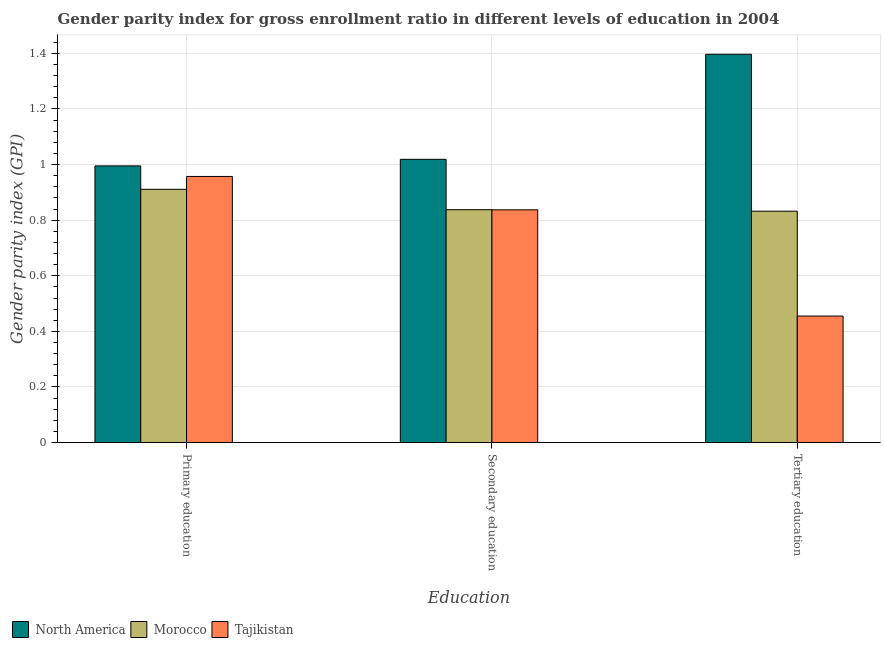How many different coloured bars are there?
Your answer should be very brief. 3. How many groups of bars are there?
Your answer should be compact. 3. How many bars are there on the 1st tick from the right?
Provide a short and direct response. 3. What is the label of the 3rd group of bars from the left?
Ensure brevity in your answer.  Tertiary education. What is the gender parity index in primary education in Morocco?
Give a very brief answer. 0.91. Across all countries, what is the maximum gender parity index in secondary education?
Offer a very short reply. 1.02. Across all countries, what is the minimum gender parity index in secondary education?
Your answer should be very brief. 0.84. In which country was the gender parity index in primary education minimum?
Provide a short and direct response. Morocco. What is the total gender parity index in secondary education in the graph?
Your answer should be very brief. 2.69. What is the difference between the gender parity index in primary education in Morocco and that in North America?
Provide a short and direct response. -0.08. What is the difference between the gender parity index in primary education in North America and the gender parity index in tertiary education in Tajikistan?
Provide a short and direct response. 0.54. What is the average gender parity index in primary education per country?
Keep it short and to the point. 0.95. What is the difference between the gender parity index in tertiary education and gender parity index in secondary education in Morocco?
Offer a terse response. -0.01. What is the ratio of the gender parity index in secondary education in North America to that in Tajikistan?
Keep it short and to the point. 1.22. Is the gender parity index in tertiary education in North America less than that in Tajikistan?
Make the answer very short. No. Is the difference between the gender parity index in tertiary education in Morocco and North America greater than the difference between the gender parity index in secondary education in Morocco and North America?
Provide a short and direct response. No. What is the difference between the highest and the second highest gender parity index in secondary education?
Provide a succinct answer. 0.18. What is the difference between the highest and the lowest gender parity index in secondary education?
Your answer should be very brief. 0.18. What does the 2nd bar from the left in Primary education represents?
Make the answer very short. Morocco. What does the 2nd bar from the right in Secondary education represents?
Make the answer very short. Morocco. How many bars are there?
Keep it short and to the point. 9. What is the difference between two consecutive major ticks on the Y-axis?
Offer a terse response. 0.2. Are the values on the major ticks of Y-axis written in scientific E-notation?
Your answer should be compact. No. How many legend labels are there?
Your answer should be compact. 3. How are the legend labels stacked?
Your answer should be compact. Horizontal. What is the title of the graph?
Your answer should be compact. Gender parity index for gross enrollment ratio in different levels of education in 2004. Does "Sri Lanka" appear as one of the legend labels in the graph?
Make the answer very short. No. What is the label or title of the X-axis?
Ensure brevity in your answer.  Education. What is the label or title of the Y-axis?
Give a very brief answer. Gender parity index (GPI). What is the Gender parity index (GPI) of North America in Primary education?
Ensure brevity in your answer.  1. What is the Gender parity index (GPI) of Morocco in Primary education?
Give a very brief answer. 0.91. What is the Gender parity index (GPI) in Tajikistan in Primary education?
Provide a short and direct response. 0.96. What is the Gender parity index (GPI) of North America in Secondary education?
Ensure brevity in your answer.  1.02. What is the Gender parity index (GPI) of Morocco in Secondary education?
Your answer should be very brief. 0.84. What is the Gender parity index (GPI) in Tajikistan in Secondary education?
Your answer should be very brief. 0.84. What is the Gender parity index (GPI) of North America in Tertiary education?
Your answer should be very brief. 1.4. What is the Gender parity index (GPI) of Morocco in Tertiary education?
Keep it short and to the point. 0.83. What is the Gender parity index (GPI) of Tajikistan in Tertiary education?
Give a very brief answer. 0.46. Across all Education, what is the maximum Gender parity index (GPI) in North America?
Offer a very short reply. 1.4. Across all Education, what is the maximum Gender parity index (GPI) of Morocco?
Provide a succinct answer. 0.91. Across all Education, what is the maximum Gender parity index (GPI) of Tajikistan?
Offer a terse response. 0.96. Across all Education, what is the minimum Gender parity index (GPI) of North America?
Give a very brief answer. 1. Across all Education, what is the minimum Gender parity index (GPI) in Morocco?
Provide a succinct answer. 0.83. Across all Education, what is the minimum Gender parity index (GPI) in Tajikistan?
Your answer should be very brief. 0.46. What is the total Gender parity index (GPI) in North America in the graph?
Your answer should be very brief. 3.41. What is the total Gender parity index (GPI) of Morocco in the graph?
Offer a very short reply. 2.58. What is the total Gender parity index (GPI) of Tajikistan in the graph?
Provide a short and direct response. 2.25. What is the difference between the Gender parity index (GPI) of North America in Primary education and that in Secondary education?
Make the answer very short. -0.02. What is the difference between the Gender parity index (GPI) in Morocco in Primary education and that in Secondary education?
Provide a short and direct response. 0.07. What is the difference between the Gender parity index (GPI) of Tajikistan in Primary education and that in Secondary education?
Offer a terse response. 0.12. What is the difference between the Gender parity index (GPI) of North America in Primary education and that in Tertiary education?
Your response must be concise. -0.4. What is the difference between the Gender parity index (GPI) in Morocco in Primary education and that in Tertiary education?
Your response must be concise. 0.08. What is the difference between the Gender parity index (GPI) in Tajikistan in Primary education and that in Tertiary education?
Offer a terse response. 0.5. What is the difference between the Gender parity index (GPI) of North America in Secondary education and that in Tertiary education?
Your answer should be very brief. -0.38. What is the difference between the Gender parity index (GPI) of Morocco in Secondary education and that in Tertiary education?
Your answer should be very brief. 0.01. What is the difference between the Gender parity index (GPI) of Tajikistan in Secondary education and that in Tertiary education?
Make the answer very short. 0.38. What is the difference between the Gender parity index (GPI) of North America in Primary education and the Gender parity index (GPI) of Morocco in Secondary education?
Your answer should be compact. 0.16. What is the difference between the Gender parity index (GPI) of North America in Primary education and the Gender parity index (GPI) of Tajikistan in Secondary education?
Offer a very short reply. 0.16. What is the difference between the Gender parity index (GPI) of Morocco in Primary education and the Gender parity index (GPI) of Tajikistan in Secondary education?
Ensure brevity in your answer.  0.07. What is the difference between the Gender parity index (GPI) of North America in Primary education and the Gender parity index (GPI) of Morocco in Tertiary education?
Offer a terse response. 0.16. What is the difference between the Gender parity index (GPI) in North America in Primary education and the Gender parity index (GPI) in Tajikistan in Tertiary education?
Offer a terse response. 0.54. What is the difference between the Gender parity index (GPI) in Morocco in Primary education and the Gender parity index (GPI) in Tajikistan in Tertiary education?
Your answer should be compact. 0.46. What is the difference between the Gender parity index (GPI) of North America in Secondary education and the Gender parity index (GPI) of Morocco in Tertiary education?
Ensure brevity in your answer.  0.19. What is the difference between the Gender parity index (GPI) of North America in Secondary education and the Gender parity index (GPI) of Tajikistan in Tertiary education?
Your response must be concise. 0.56. What is the difference between the Gender parity index (GPI) in Morocco in Secondary education and the Gender parity index (GPI) in Tajikistan in Tertiary education?
Ensure brevity in your answer.  0.38. What is the average Gender parity index (GPI) in North America per Education?
Provide a short and direct response. 1.14. What is the average Gender parity index (GPI) in Morocco per Education?
Keep it short and to the point. 0.86. What is the average Gender parity index (GPI) of Tajikistan per Education?
Offer a terse response. 0.75. What is the difference between the Gender parity index (GPI) of North America and Gender parity index (GPI) of Morocco in Primary education?
Provide a short and direct response. 0.08. What is the difference between the Gender parity index (GPI) of North America and Gender parity index (GPI) of Tajikistan in Primary education?
Provide a succinct answer. 0.04. What is the difference between the Gender parity index (GPI) in Morocco and Gender parity index (GPI) in Tajikistan in Primary education?
Offer a very short reply. -0.05. What is the difference between the Gender parity index (GPI) of North America and Gender parity index (GPI) of Morocco in Secondary education?
Keep it short and to the point. 0.18. What is the difference between the Gender parity index (GPI) in North America and Gender parity index (GPI) in Tajikistan in Secondary education?
Offer a very short reply. 0.18. What is the difference between the Gender parity index (GPI) of North America and Gender parity index (GPI) of Morocco in Tertiary education?
Keep it short and to the point. 0.56. What is the difference between the Gender parity index (GPI) in North America and Gender parity index (GPI) in Tajikistan in Tertiary education?
Offer a very short reply. 0.94. What is the difference between the Gender parity index (GPI) in Morocco and Gender parity index (GPI) in Tajikistan in Tertiary education?
Your answer should be compact. 0.38. What is the ratio of the Gender parity index (GPI) of North America in Primary education to that in Secondary education?
Your answer should be very brief. 0.98. What is the ratio of the Gender parity index (GPI) in Morocco in Primary education to that in Secondary education?
Provide a short and direct response. 1.09. What is the ratio of the Gender parity index (GPI) of Tajikistan in Primary education to that in Secondary education?
Offer a very short reply. 1.14. What is the ratio of the Gender parity index (GPI) in North America in Primary education to that in Tertiary education?
Offer a very short reply. 0.71. What is the ratio of the Gender parity index (GPI) of Morocco in Primary education to that in Tertiary education?
Offer a terse response. 1.09. What is the ratio of the Gender parity index (GPI) of Tajikistan in Primary education to that in Tertiary education?
Make the answer very short. 2.1. What is the ratio of the Gender parity index (GPI) in North America in Secondary education to that in Tertiary education?
Keep it short and to the point. 0.73. What is the ratio of the Gender parity index (GPI) of Tajikistan in Secondary education to that in Tertiary education?
Your answer should be compact. 1.84. What is the difference between the highest and the second highest Gender parity index (GPI) in North America?
Provide a short and direct response. 0.38. What is the difference between the highest and the second highest Gender parity index (GPI) in Morocco?
Ensure brevity in your answer.  0.07. What is the difference between the highest and the second highest Gender parity index (GPI) in Tajikistan?
Your response must be concise. 0.12. What is the difference between the highest and the lowest Gender parity index (GPI) of North America?
Offer a very short reply. 0.4. What is the difference between the highest and the lowest Gender parity index (GPI) of Morocco?
Your response must be concise. 0.08. What is the difference between the highest and the lowest Gender parity index (GPI) of Tajikistan?
Offer a very short reply. 0.5. 